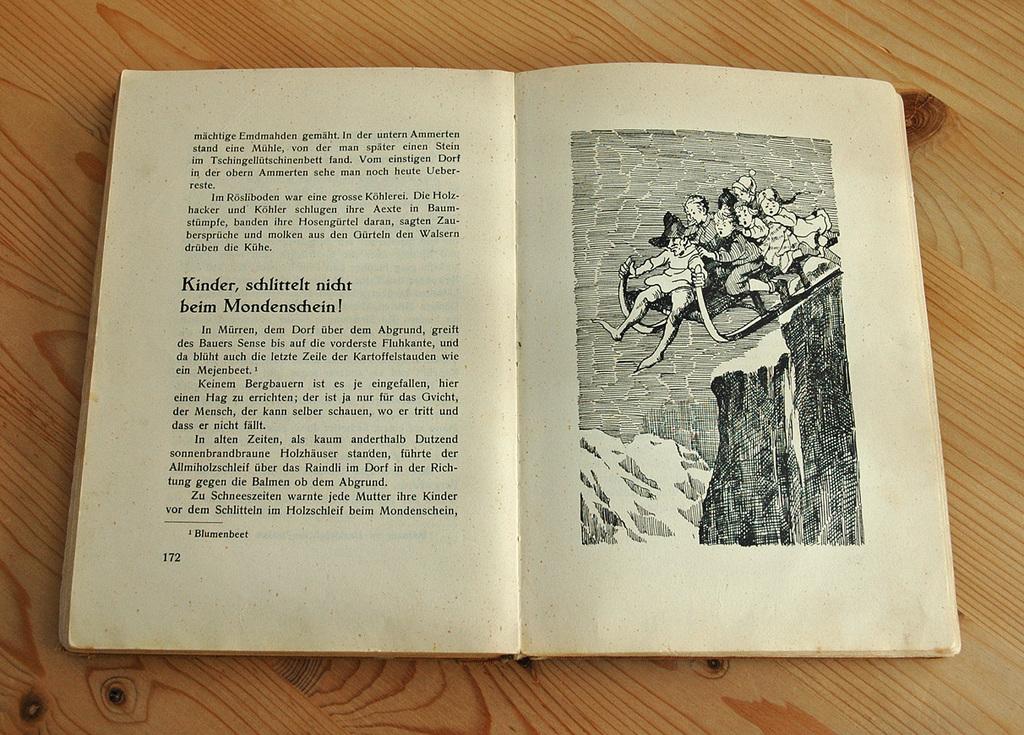What page is the book opened to?
Ensure brevity in your answer.  172. What does the first bolded word say?
Provide a short and direct response. Kinder. 